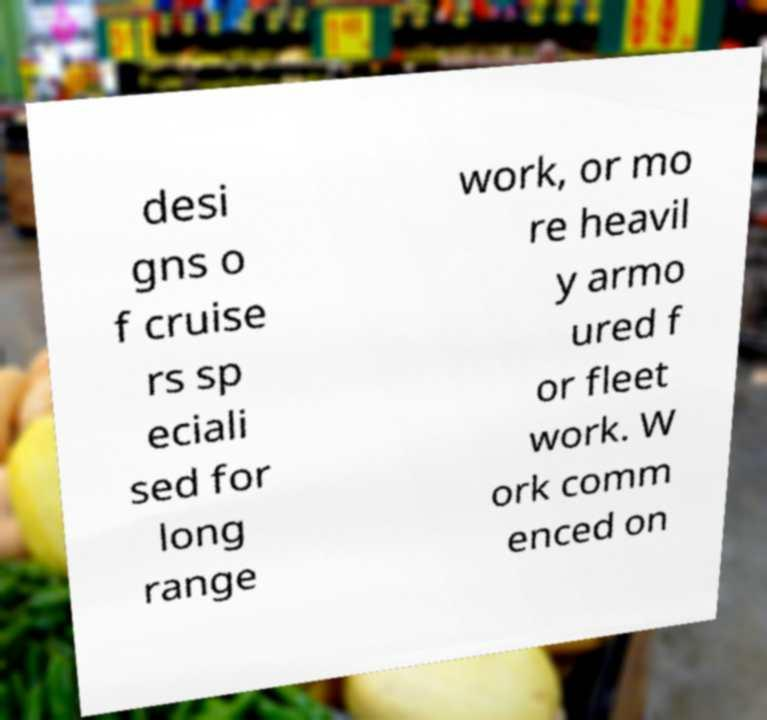There's text embedded in this image that I need extracted. Can you transcribe it verbatim? desi gns o f cruise rs sp eciali sed for long range work, or mo re heavil y armo ured f or fleet work. W ork comm enced on 